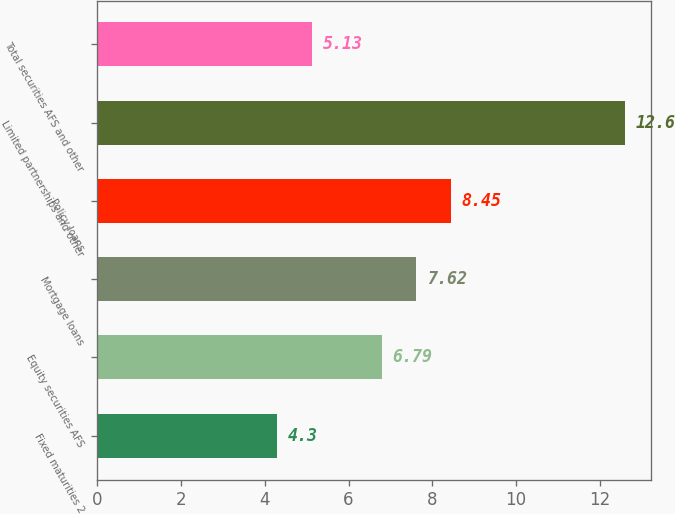Convert chart. <chart><loc_0><loc_0><loc_500><loc_500><bar_chart><fcel>Fixed maturities 2<fcel>Equity securities AFS<fcel>Mortgage loans<fcel>Policy loans<fcel>Limited partnerships and other<fcel>Total securities AFS and other<nl><fcel>4.3<fcel>6.79<fcel>7.62<fcel>8.45<fcel>12.6<fcel>5.13<nl></chart> 